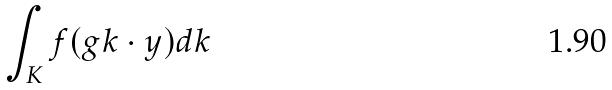<formula> <loc_0><loc_0><loc_500><loc_500>\int _ { K } f ( g k \cdot y ) d k</formula> 